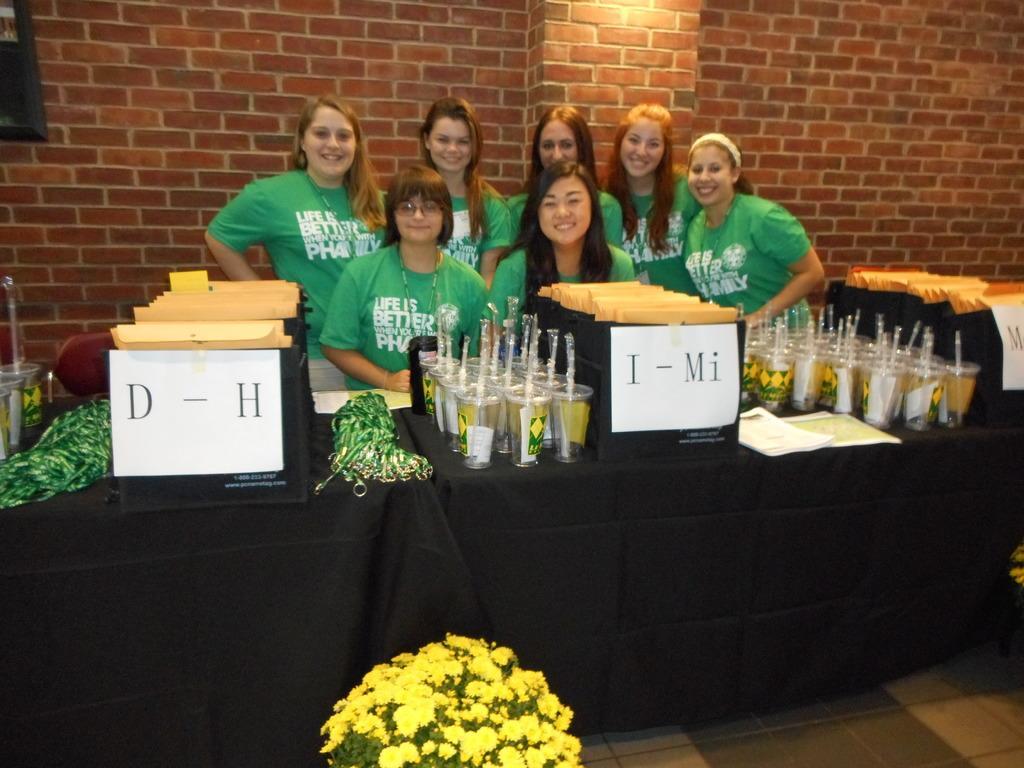Describe this image in one or two sentences. We can see flowers and floor. There are people smiling and we can see glasses with straws and objects on the table. In the background we can see frame on the wall. 